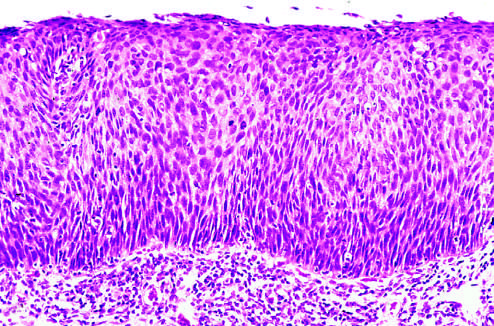s the transmural light area in the posterolateral left ventricle replaced by atypical dysplastic cells?
Answer the question using a single word or phrase. No 